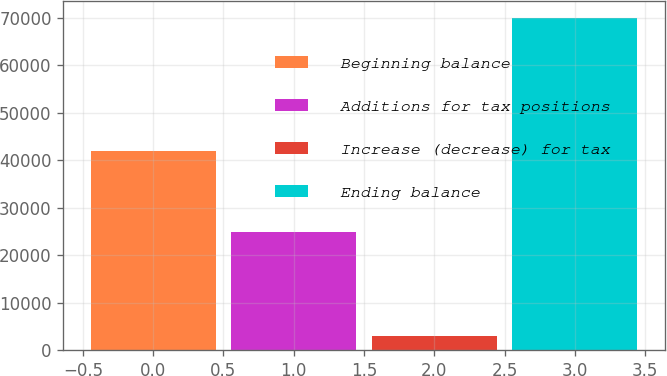<chart> <loc_0><loc_0><loc_500><loc_500><bar_chart><fcel>Beginning balance<fcel>Additions for tax positions<fcel>Increase (decrease) for tax<fcel>Ending balance<nl><fcel>42011<fcel>24905<fcel>3083<fcel>69999<nl></chart> 